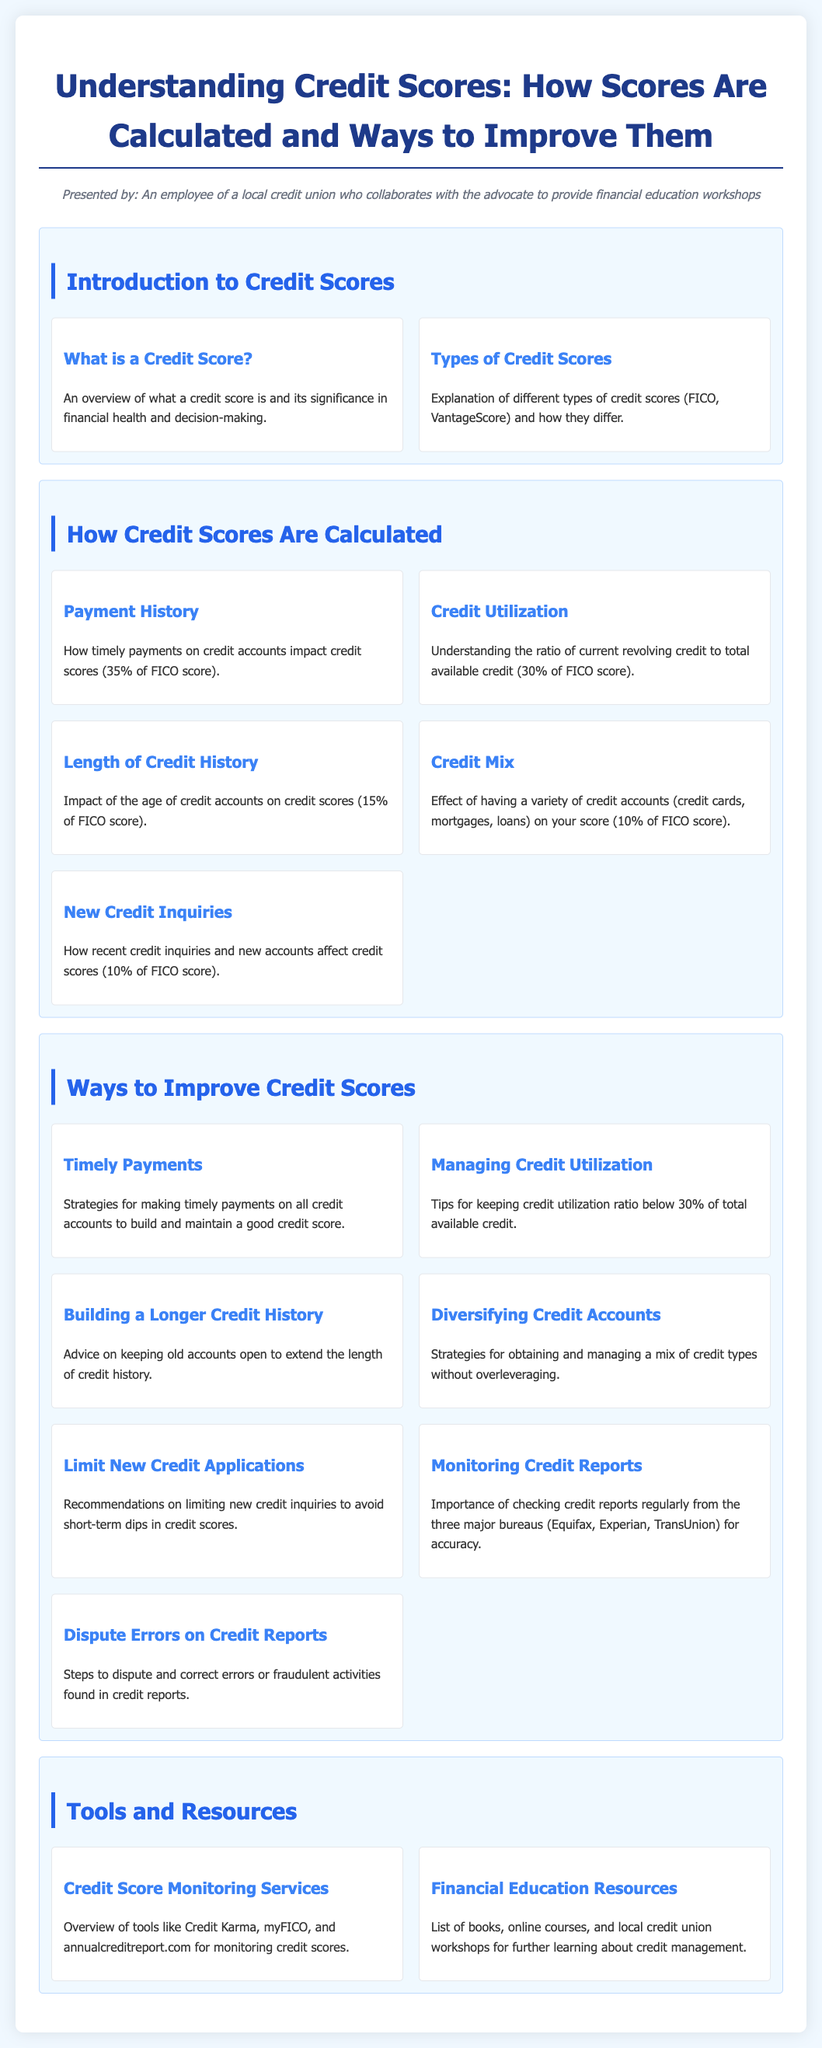What is a credit score? A credit score is an overview of what a credit score is and its significance in financial health and decision-making.
Answer: An overview of what a credit score is and its significance in financial health and decision-making What percentage of the FICO score does payment history represent? The document specifies that payment history accounts for 35% of the FICO score calculation.
Answer: 35% What is one way to improve credit scores? The document lists several strategies, including making timely payments on all credit accounts.
Answer: Strategies for making timely payments on all credit accounts to build and maintain a good credit score How many types of credit scores are explained in the syllabus? The syllabus discusses FICO and VantageScore as different types of credit scores, indicating there are two.
Answer: Two What does credit utilization represent in the FICO score calculation? The document defines credit utilization as the ratio of current revolving credit to total available credit, accounting for 30% of the FICO score.
Answer: 30% What is the importance of monitoring credit reports? The importance of checking credit reports regularly is highlighted for accuracy regarding information that impacts credit scores.
Answer: Importance of checking credit reports regularly from the three major bureaus for accuracy What is the outcome of limiting new credit applications? The document suggests limiting new credit inquiries to avoid short-term dips in credit scores.
Answer: To avoid short-term dips in credit scores Which tools are mentioned for monitoring credit scores? The syllabus provides an overview of tools like Credit Karma, myFICO, and annualcreditreport.com for monitoring credit scores.
Answer: Credit Karma, myFICO, and annualcreditreport.com 